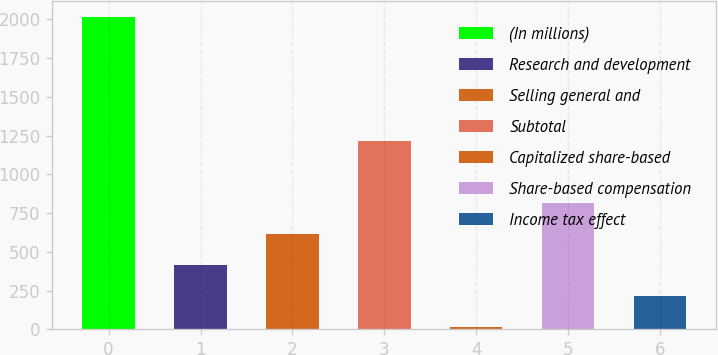<chart> <loc_0><loc_0><loc_500><loc_500><bar_chart><fcel>(In millions)<fcel>Research and development<fcel>Selling general and<fcel>Subtotal<fcel>Capitalized share-based<fcel>Share-based compensation<fcel>Income tax effect<nl><fcel>2016<fcel>414.88<fcel>615.02<fcel>1215.44<fcel>14.6<fcel>815.16<fcel>214.74<nl></chart> 